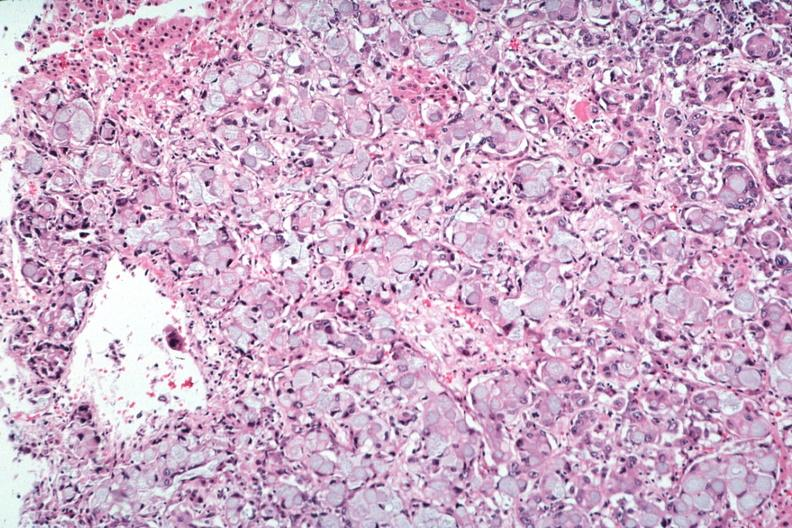what does this image show?
Answer the question using a single word or phrase. Primary in stomach 